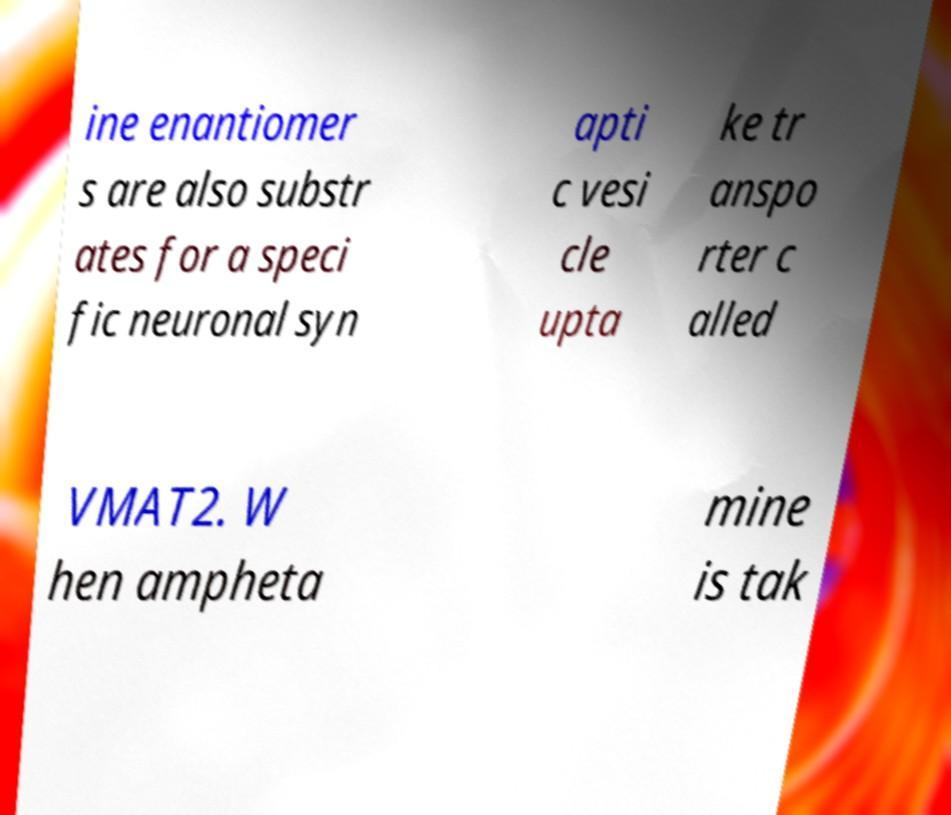There's text embedded in this image that I need extracted. Can you transcribe it verbatim? ine enantiomer s are also substr ates for a speci fic neuronal syn apti c vesi cle upta ke tr anspo rter c alled VMAT2. W hen ampheta mine is tak 